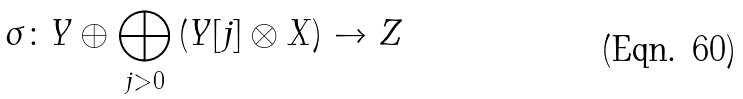Convert formula to latex. <formula><loc_0><loc_0><loc_500><loc_500>\sigma \colon Y \oplus \bigoplus _ { j > 0 } \left ( Y [ j ] \otimes X \right ) \to Z</formula> 